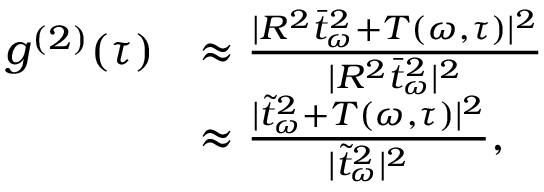Convert formula to latex. <formula><loc_0><loc_0><loc_500><loc_500>\begin{array} { r l } { g ^ { ( 2 ) } ( \tau ) } & { \approx \frac { | R ^ { 2 } \bar { t } _ { \omega } ^ { 2 } + T ( \omega , \tau ) | ^ { 2 } } { | R ^ { 2 } \bar { t } _ { \omega } ^ { 2 } | ^ { 2 } } } \\ & { \approx \frac { | \tilde { t } _ { \omega } ^ { 2 } + T ( \omega , \tau ) | ^ { 2 } } { | \tilde { t } _ { \omega } ^ { 2 } | ^ { 2 } } , } \end{array}</formula> 